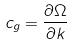<formula> <loc_0><loc_0><loc_500><loc_500>c _ { g } = \frac { \partial \Omega } { \partial k }</formula> 